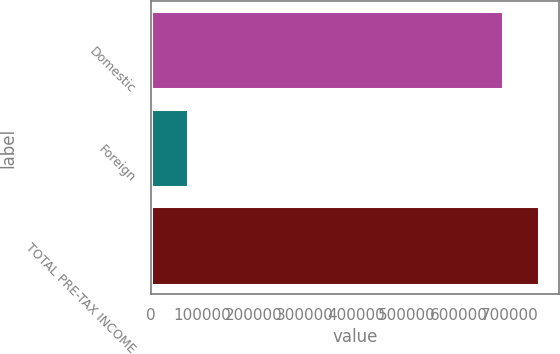Convert chart to OTSL. <chart><loc_0><loc_0><loc_500><loc_500><bar_chart><fcel>Domestic<fcel>Foreign<fcel>TOTAL PRE-TAX INCOME<nl><fcel>686571<fcel>71180<fcel>757751<nl></chart> 